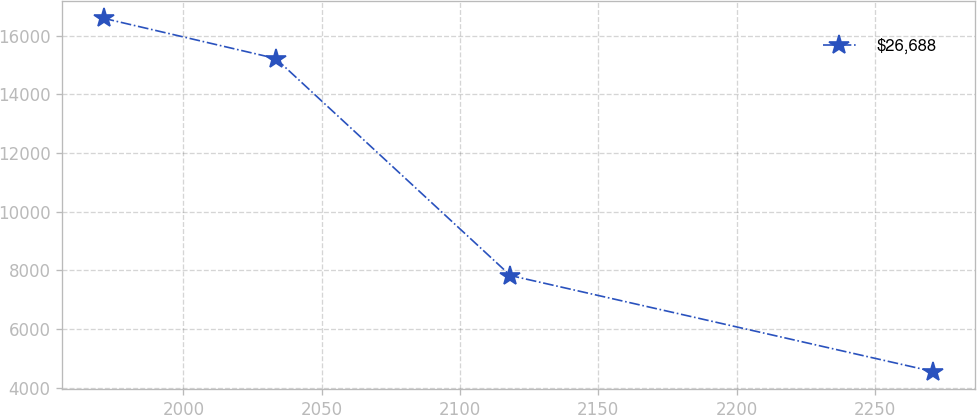Convert chart to OTSL. <chart><loc_0><loc_0><loc_500><loc_500><line_chart><ecel><fcel>$26,688<nl><fcel>1971.16<fcel>16593.3<nl><fcel>2033.4<fcel>15222.6<nl><fcel>2118.24<fcel>7825.43<nl><fcel>2271.07<fcel>4552.84<nl></chart> 